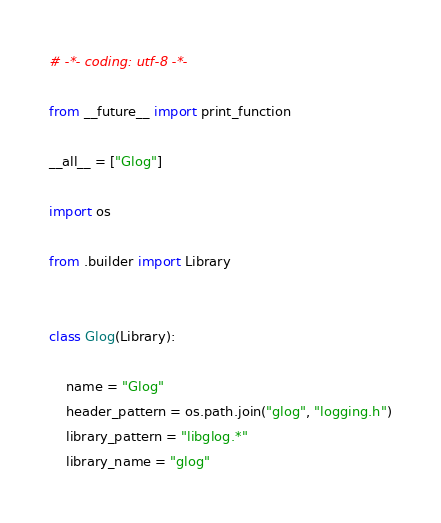Convert code to text. <code><loc_0><loc_0><loc_500><loc_500><_Python_># -*- coding: utf-8 -*-

from __future__ import print_function

__all__ = ["Glog"]

import os

from .builder import Library


class Glog(Library):

    name = "Glog"
    header_pattern = os.path.join("glog", "logging.h")
    library_pattern = "libglog.*"
    library_name = "glog"
</code> 